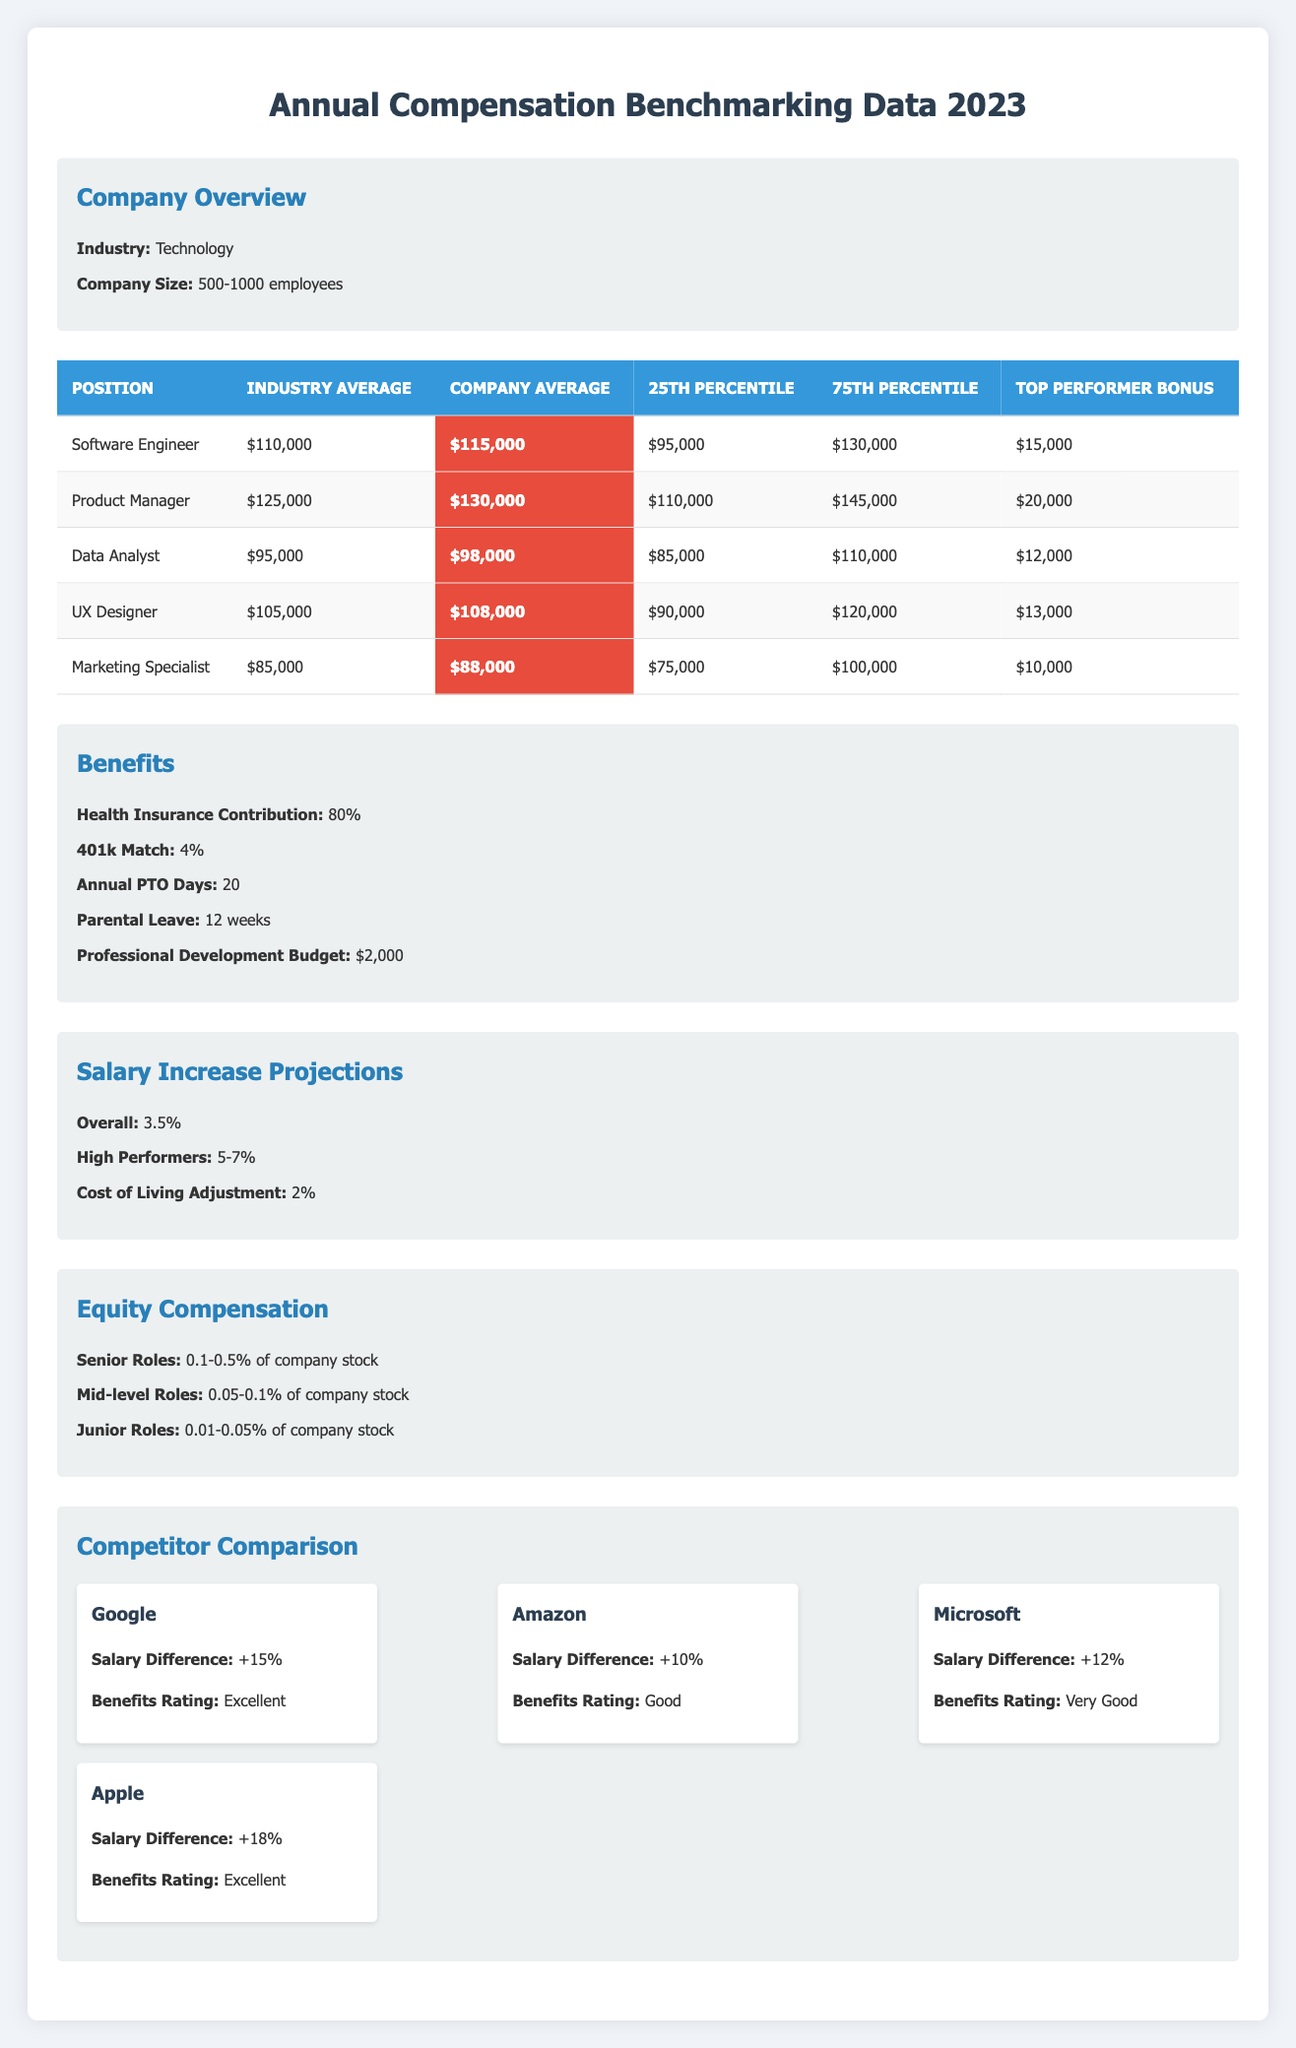What is the company average salary for a Software Engineer? The company average salary for a Software Engineer is directly listed in the table under the "Company Average" column for that position. It shows $115,000.
Answer: $115,000 What is the top performer bonus for a Product Manager? The top performer bonus for a Product Manager is located in the table under the "Top Performer Bonus" column for that position, which states $20,000.
Answer: $20,000 How much does the company contribute to health insurance? The company contributes 80% to health insurance as stated in the benefits section of the table.
Answer: 80% Is the company average salary for a Data Analyst greater than the industry average salary? The company average salary for a Data Analyst is $98,000 while the industry average salary is $95,000. Since $98,000 is greater than $95,000, the statement is true.
Answer: Yes What is the average salary difference between the company and Google? Google has an average salary difference of +15% compared to our company. To find the absolute difference, we calculate the difference: $115,000 * 0.15 = $17,250. Adding this to the company's average salary gives $115,000 + $17,250 = $132,250. Therefore, Google’s average salary is $132,250.
Answer: $132,250 How many positions have a top performer bonus greater than $12,000? We can count the top performer bonuses from the table. The positions with bonuses greater than $12,000 are Software Engineer ($15,000), Product Manager ($20,000), and UX Designer ($13,000). This gives us a total of 3 positions.
Answer: 3 What is the 25th percentile salary for a UX Designer? The 25th percentile salary for UX Designer is listed in the table under the "25th Percentile" column for that position, which shows $90,000.
Answer: $90,000 Which position has the highest industry average salary, and what is that amount? Looking at the "Industry Average" column, we can see that the Product Manager has the highest industry average salary of $125,000.
Answer: Product Manager, $125,000 What is the average salary for all positions listed in the table? To find the average salary for all positions, we add the company averages for all five positions: $115,000 + $130,000 + $98,000 + $108,000 + $88,000 = $639,000. There are 5 positions, so the average salary is $639,000 / 5 = $127,800.
Answer: $127,800 